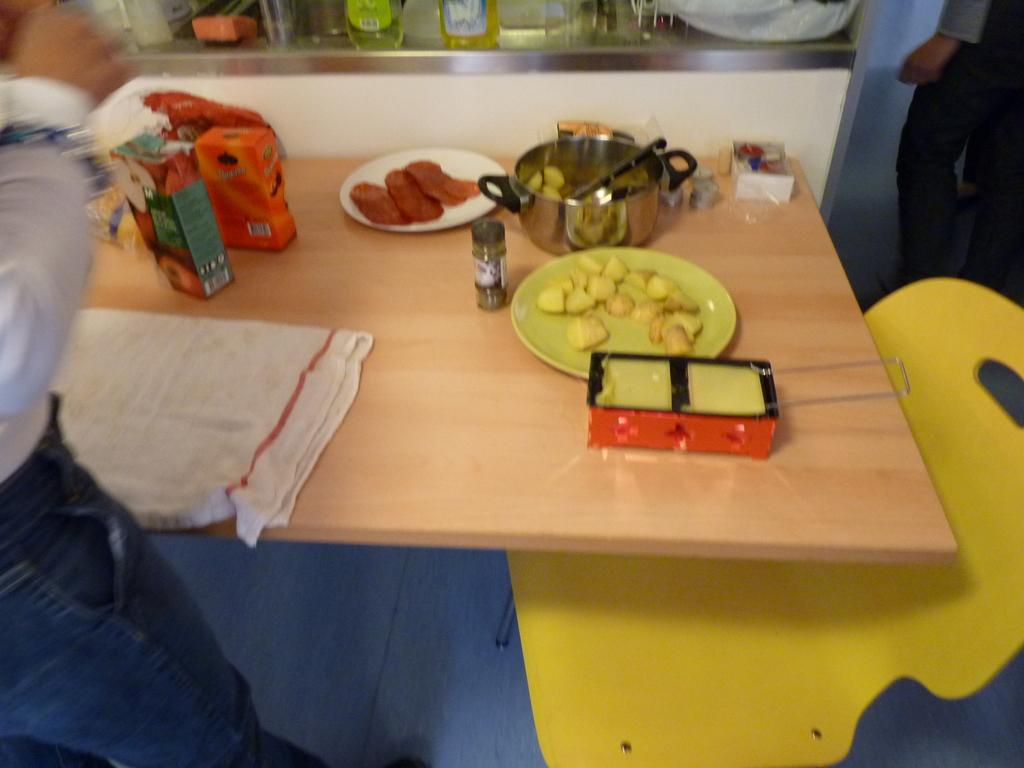What is the main subject of the image? The main subject of the image is food served on plates. Where is the food located in the image? The food is on a table in the image. What else can be seen related to food in the image? There are food packets in the image. What type of knee can be seen supporting the table in the image? There is no knee visible in the image; the table is likely supported by legs or a stand. 